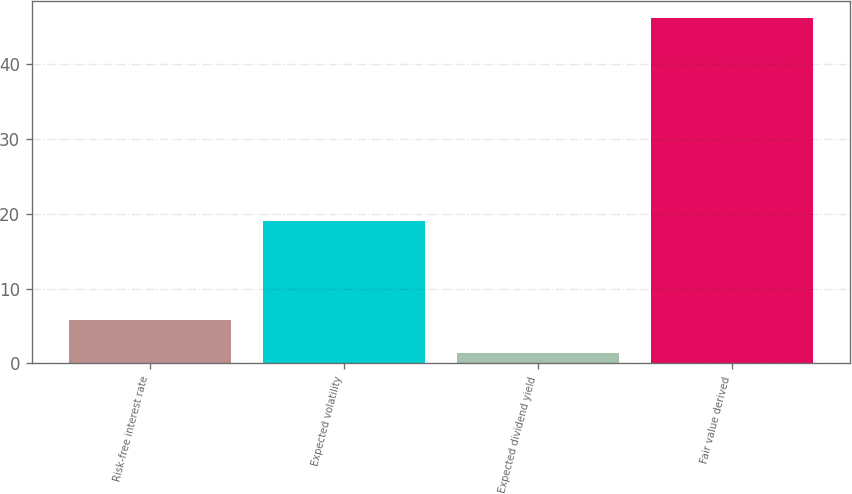<chart> <loc_0><loc_0><loc_500><loc_500><bar_chart><fcel>Risk-free interest rate<fcel>Expected volatility<fcel>Expected dividend yield<fcel>Fair value derived<nl><fcel>5.81<fcel>19<fcel>1.33<fcel>46.1<nl></chart> 